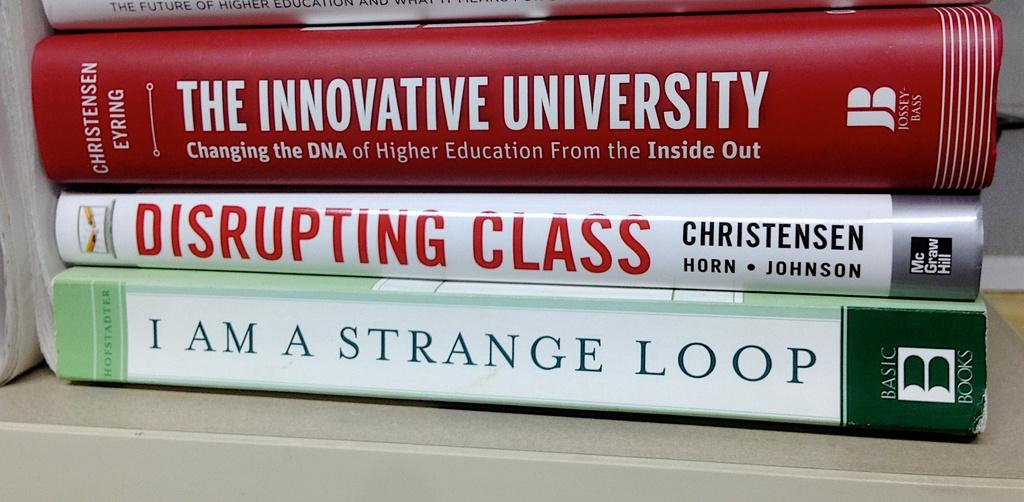<image>
Relay a brief, clear account of the picture shown. A stack of books called Disrupting Class and The Innovative University. 